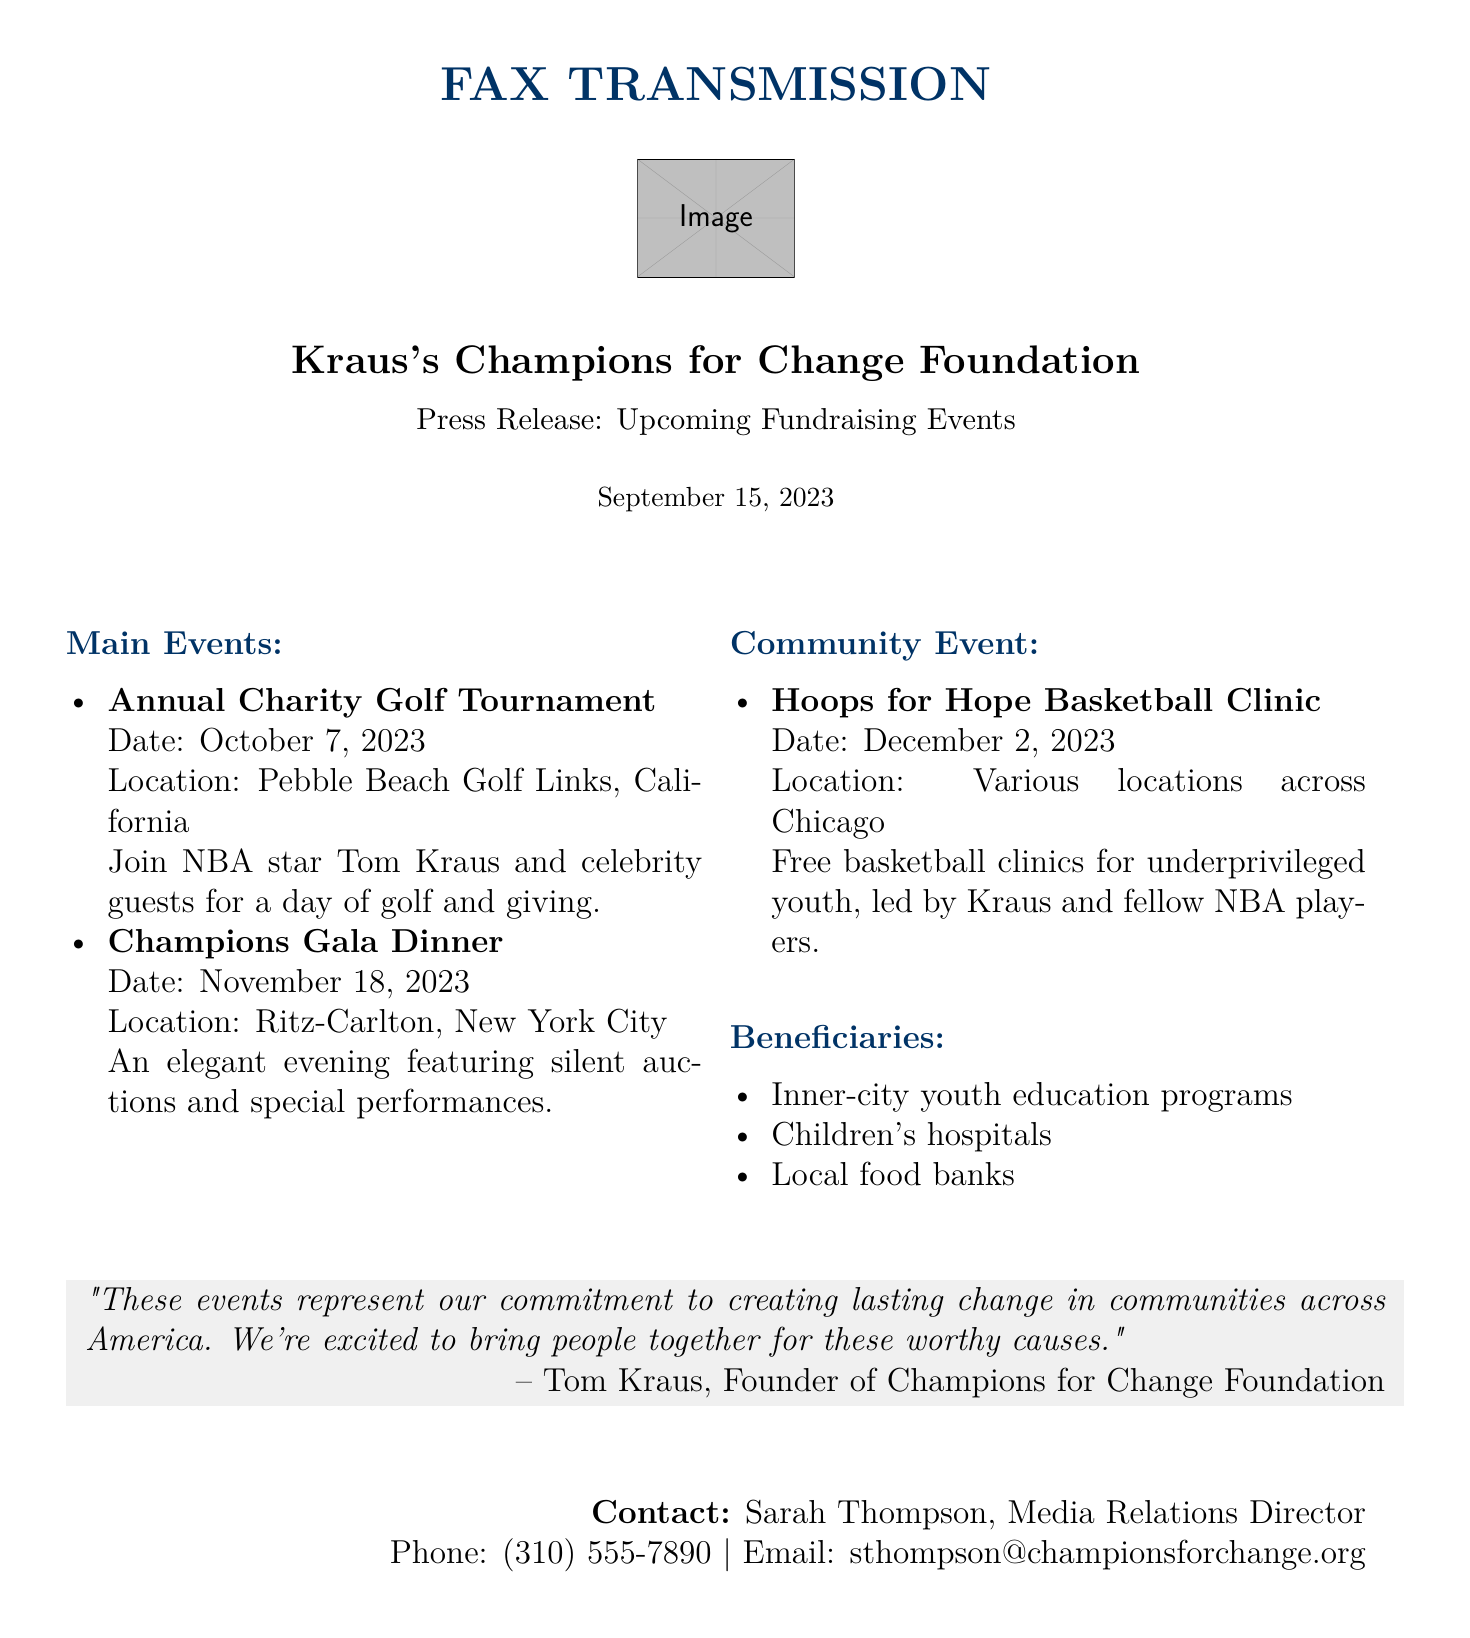What is the date of the Annual Charity Golf Tournament? The date is explicitly stated in the document under the Annual Charity Golf Tournament section.
Answer: October 7, 2023 Where will the Champions Gala Dinner be held? The location of the Champions Gala Dinner is clearly indicated in the document.
Answer: Ritz-Carlton, New York City Who is the founder of the Champions for Change Foundation? The founder is mentioned in the quote at the end of the document.
Answer: Tom Kraus What is the purpose of the Hoops for Hope Basketball Clinic? The purpose is described in the document, focusing on its target audience and activity.
Answer: Free basketball clinics for underprivileged youth Which celebrity will participate in the Annual Charity Golf Tournament? The document mentions a specific celebrity who will be present at the event.
Answer: NBA star Tom Kraus What are the beneficiaries mentioned in the press release? The document lists specific beneficiaries of the fundraising events.
Answer: Inner-city youth education programs, Children's hospitals, Local food banks What type of event is scheduled for December 2, 2023? The document specifies the nature of the event occurring on this date.
Answer: Basketball Clinic Who should be contacted for media inquiries? The document provides contact information for media relations in the footer.
Answer: Sarah Thompson, Media Relations Director 